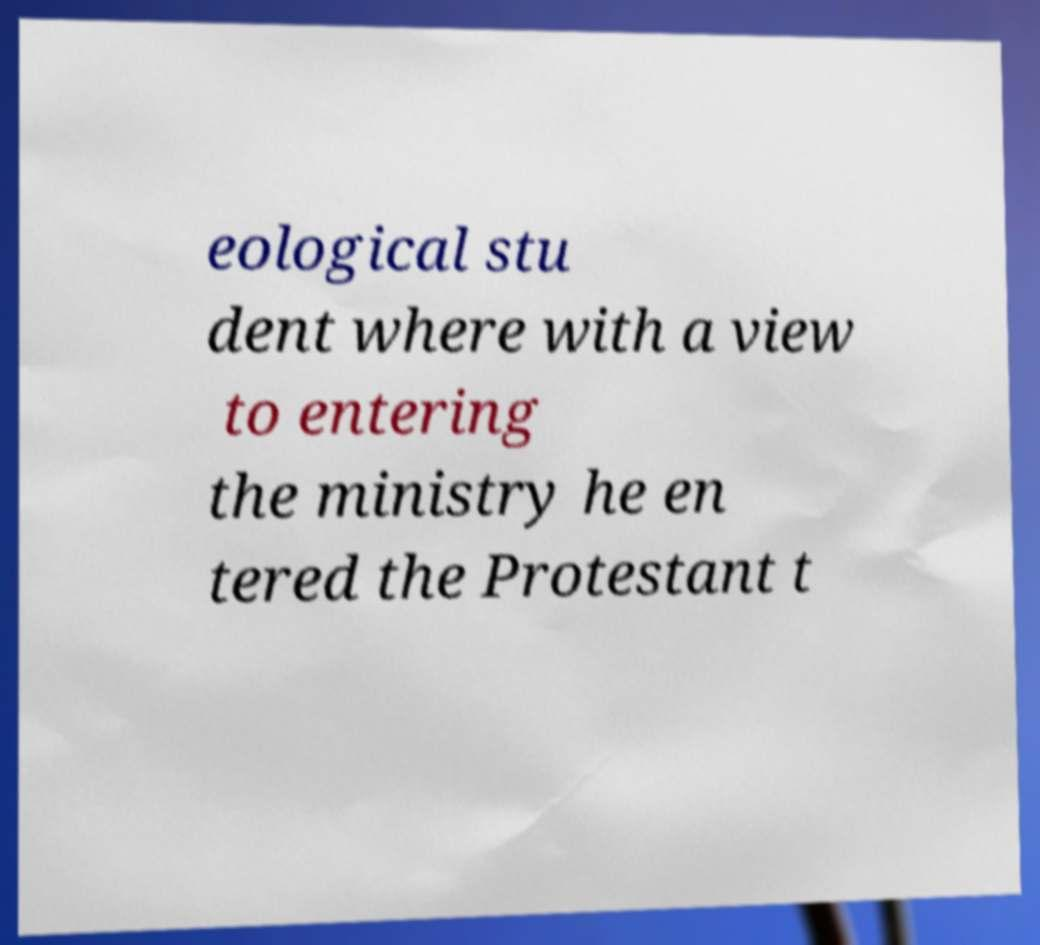Could you assist in decoding the text presented in this image and type it out clearly? eological stu dent where with a view to entering the ministry he en tered the Protestant t 